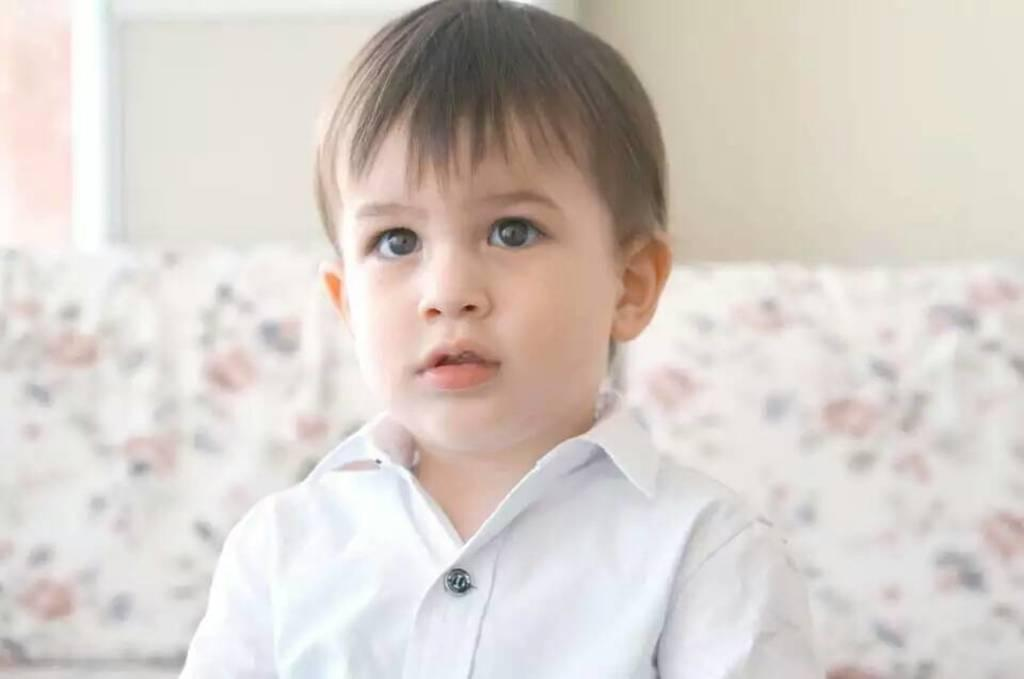Who is the main subject in the image? There is a boy in the image. What is the boy wearing? The boy is wearing a white shirt. What can be seen behind the boy? There is an object behind the boy. What is the background of the image? There is a wall behind the object. How many matches does the boy have in his hand in the image? There are no matches present in the image. What is the boy's brother doing in the image? There is no mention of a brother in the image, so it cannot be determined what the brother might be doing. 